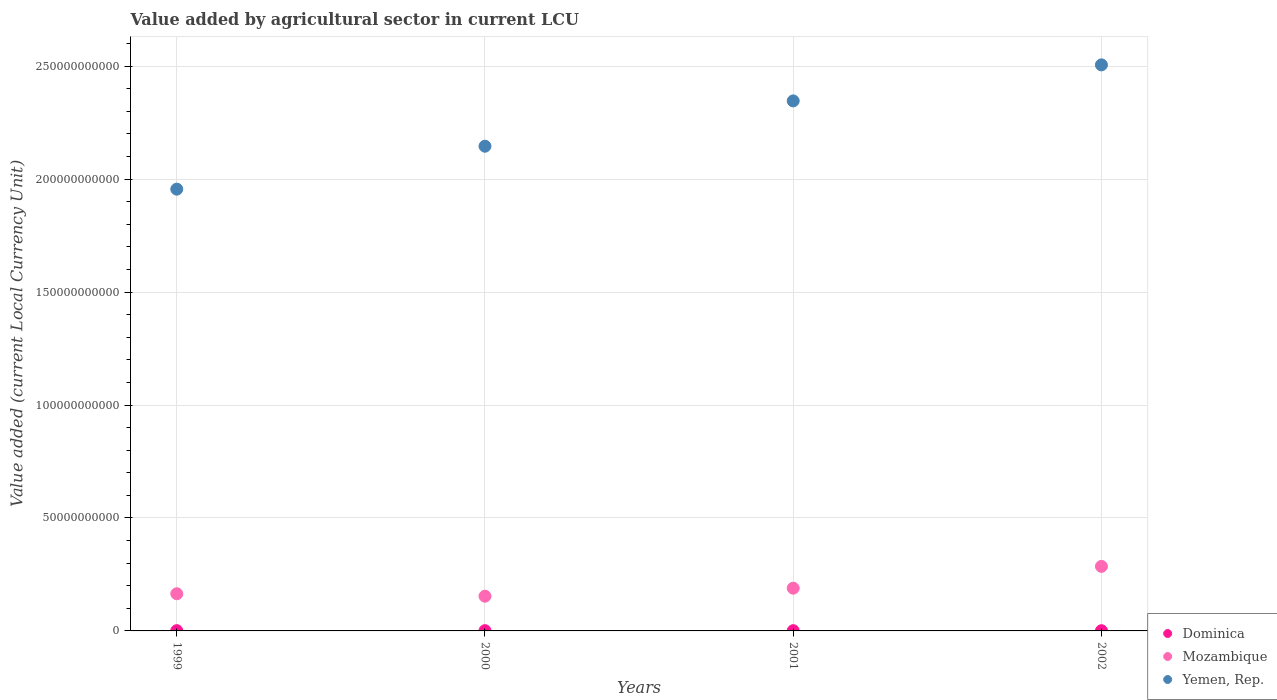Is the number of dotlines equal to the number of legend labels?
Offer a very short reply. Yes. What is the value added by agricultural sector in Yemen, Rep. in 2000?
Provide a succinct answer. 2.15e+11. Across all years, what is the maximum value added by agricultural sector in Yemen, Rep.?
Your response must be concise. 2.51e+11. Across all years, what is the minimum value added by agricultural sector in Yemen, Rep.?
Your response must be concise. 1.96e+11. In which year was the value added by agricultural sector in Yemen, Rep. maximum?
Provide a succinct answer. 2002. What is the total value added by agricultural sector in Dominica in the graph?
Your answer should be very brief. 4.23e+08. What is the difference between the value added by agricultural sector in Yemen, Rep. in 2000 and that in 2001?
Provide a short and direct response. -2.01e+1. What is the difference between the value added by agricultural sector in Dominica in 2002 and the value added by agricultural sector in Mozambique in 1999?
Your answer should be compact. -1.64e+1. What is the average value added by agricultural sector in Yemen, Rep. per year?
Your answer should be compact. 2.24e+11. In the year 1999, what is the difference between the value added by agricultural sector in Mozambique and value added by agricultural sector in Dominica?
Offer a very short reply. 1.63e+1. What is the ratio of the value added by agricultural sector in Dominica in 1999 to that in 2002?
Keep it short and to the point. 1.17. Is the difference between the value added by agricultural sector in Mozambique in 1999 and 2001 greater than the difference between the value added by agricultural sector in Dominica in 1999 and 2001?
Provide a succinct answer. No. What is the difference between the highest and the second highest value added by agricultural sector in Dominica?
Your answer should be very brief. 6.93e+06. What is the difference between the highest and the lowest value added by agricultural sector in Yemen, Rep.?
Ensure brevity in your answer.  5.50e+1. Is the sum of the value added by agricultural sector in Dominica in 1999 and 2001 greater than the maximum value added by agricultural sector in Yemen, Rep. across all years?
Your response must be concise. No. Does the value added by agricultural sector in Mozambique monotonically increase over the years?
Provide a short and direct response. No. How many dotlines are there?
Your response must be concise. 3. How many years are there in the graph?
Offer a very short reply. 4. What is the difference between two consecutive major ticks on the Y-axis?
Offer a very short reply. 5.00e+1. Are the values on the major ticks of Y-axis written in scientific E-notation?
Offer a terse response. No. Does the graph contain any zero values?
Ensure brevity in your answer.  No. What is the title of the graph?
Make the answer very short. Value added by agricultural sector in current LCU. What is the label or title of the X-axis?
Provide a succinct answer. Years. What is the label or title of the Y-axis?
Give a very brief answer. Value added (current Local Currency Unit). What is the Value added (current Local Currency Unit) of Dominica in 1999?
Ensure brevity in your answer.  1.14e+08. What is the Value added (current Local Currency Unit) of Mozambique in 1999?
Offer a very short reply. 1.65e+1. What is the Value added (current Local Currency Unit) in Yemen, Rep. in 1999?
Give a very brief answer. 1.96e+11. What is the Value added (current Local Currency Unit) in Dominica in 2000?
Your answer should be compact. 1.07e+08. What is the Value added (current Local Currency Unit) of Mozambique in 2000?
Give a very brief answer. 1.54e+1. What is the Value added (current Local Currency Unit) of Yemen, Rep. in 2000?
Make the answer very short. 2.15e+11. What is the Value added (current Local Currency Unit) of Dominica in 2001?
Give a very brief answer. 1.04e+08. What is the Value added (current Local Currency Unit) of Mozambique in 2001?
Provide a short and direct response. 1.89e+1. What is the Value added (current Local Currency Unit) in Yemen, Rep. in 2001?
Offer a terse response. 2.35e+11. What is the Value added (current Local Currency Unit) in Dominica in 2002?
Ensure brevity in your answer.  9.75e+07. What is the Value added (current Local Currency Unit) in Mozambique in 2002?
Provide a succinct answer. 2.86e+1. What is the Value added (current Local Currency Unit) in Yemen, Rep. in 2002?
Your response must be concise. 2.51e+11. Across all years, what is the maximum Value added (current Local Currency Unit) in Dominica?
Provide a succinct answer. 1.14e+08. Across all years, what is the maximum Value added (current Local Currency Unit) of Mozambique?
Keep it short and to the point. 2.86e+1. Across all years, what is the maximum Value added (current Local Currency Unit) in Yemen, Rep.?
Your answer should be very brief. 2.51e+11. Across all years, what is the minimum Value added (current Local Currency Unit) in Dominica?
Give a very brief answer. 9.75e+07. Across all years, what is the minimum Value added (current Local Currency Unit) of Mozambique?
Offer a terse response. 1.54e+1. Across all years, what is the minimum Value added (current Local Currency Unit) in Yemen, Rep.?
Offer a terse response. 1.96e+11. What is the total Value added (current Local Currency Unit) in Dominica in the graph?
Ensure brevity in your answer.  4.23e+08. What is the total Value added (current Local Currency Unit) in Mozambique in the graph?
Your response must be concise. 7.93e+1. What is the total Value added (current Local Currency Unit) of Yemen, Rep. in the graph?
Give a very brief answer. 8.95e+11. What is the difference between the Value added (current Local Currency Unit) of Dominica in 1999 and that in 2000?
Your answer should be very brief. 6.93e+06. What is the difference between the Value added (current Local Currency Unit) in Mozambique in 1999 and that in 2000?
Your response must be concise. 1.09e+09. What is the difference between the Value added (current Local Currency Unit) of Yemen, Rep. in 1999 and that in 2000?
Make the answer very short. -1.90e+1. What is the difference between the Value added (current Local Currency Unit) of Dominica in 1999 and that in 2001?
Offer a terse response. 1.04e+07. What is the difference between the Value added (current Local Currency Unit) in Mozambique in 1999 and that in 2001?
Provide a succinct answer. -2.47e+09. What is the difference between the Value added (current Local Currency Unit) of Yemen, Rep. in 1999 and that in 2001?
Offer a very short reply. -3.91e+1. What is the difference between the Value added (current Local Currency Unit) of Dominica in 1999 and that in 2002?
Make the answer very short. 1.66e+07. What is the difference between the Value added (current Local Currency Unit) in Mozambique in 1999 and that in 2002?
Your answer should be very brief. -1.21e+1. What is the difference between the Value added (current Local Currency Unit) of Yemen, Rep. in 1999 and that in 2002?
Your response must be concise. -5.50e+1. What is the difference between the Value added (current Local Currency Unit) of Dominica in 2000 and that in 2001?
Your answer should be compact. 3.43e+06. What is the difference between the Value added (current Local Currency Unit) in Mozambique in 2000 and that in 2001?
Your response must be concise. -3.56e+09. What is the difference between the Value added (current Local Currency Unit) in Yemen, Rep. in 2000 and that in 2001?
Offer a very short reply. -2.01e+1. What is the difference between the Value added (current Local Currency Unit) in Dominica in 2000 and that in 2002?
Make the answer very short. 9.66e+06. What is the difference between the Value added (current Local Currency Unit) in Mozambique in 2000 and that in 2002?
Make the answer very short. -1.32e+1. What is the difference between the Value added (current Local Currency Unit) of Yemen, Rep. in 2000 and that in 2002?
Your answer should be very brief. -3.60e+1. What is the difference between the Value added (current Local Currency Unit) of Dominica in 2001 and that in 2002?
Your answer should be very brief. 6.23e+06. What is the difference between the Value added (current Local Currency Unit) of Mozambique in 2001 and that in 2002?
Your answer should be very brief. -9.65e+09. What is the difference between the Value added (current Local Currency Unit) in Yemen, Rep. in 2001 and that in 2002?
Offer a very short reply. -1.60e+1. What is the difference between the Value added (current Local Currency Unit) of Dominica in 1999 and the Value added (current Local Currency Unit) of Mozambique in 2000?
Provide a short and direct response. -1.53e+1. What is the difference between the Value added (current Local Currency Unit) in Dominica in 1999 and the Value added (current Local Currency Unit) in Yemen, Rep. in 2000?
Make the answer very short. -2.14e+11. What is the difference between the Value added (current Local Currency Unit) in Mozambique in 1999 and the Value added (current Local Currency Unit) in Yemen, Rep. in 2000?
Your response must be concise. -1.98e+11. What is the difference between the Value added (current Local Currency Unit) of Dominica in 1999 and the Value added (current Local Currency Unit) of Mozambique in 2001?
Keep it short and to the point. -1.88e+1. What is the difference between the Value added (current Local Currency Unit) in Dominica in 1999 and the Value added (current Local Currency Unit) in Yemen, Rep. in 2001?
Offer a very short reply. -2.34e+11. What is the difference between the Value added (current Local Currency Unit) in Mozambique in 1999 and the Value added (current Local Currency Unit) in Yemen, Rep. in 2001?
Ensure brevity in your answer.  -2.18e+11. What is the difference between the Value added (current Local Currency Unit) of Dominica in 1999 and the Value added (current Local Currency Unit) of Mozambique in 2002?
Offer a very short reply. -2.85e+1. What is the difference between the Value added (current Local Currency Unit) in Dominica in 1999 and the Value added (current Local Currency Unit) in Yemen, Rep. in 2002?
Keep it short and to the point. -2.50e+11. What is the difference between the Value added (current Local Currency Unit) of Mozambique in 1999 and the Value added (current Local Currency Unit) of Yemen, Rep. in 2002?
Ensure brevity in your answer.  -2.34e+11. What is the difference between the Value added (current Local Currency Unit) in Dominica in 2000 and the Value added (current Local Currency Unit) in Mozambique in 2001?
Your response must be concise. -1.88e+1. What is the difference between the Value added (current Local Currency Unit) in Dominica in 2000 and the Value added (current Local Currency Unit) in Yemen, Rep. in 2001?
Ensure brevity in your answer.  -2.35e+11. What is the difference between the Value added (current Local Currency Unit) of Mozambique in 2000 and the Value added (current Local Currency Unit) of Yemen, Rep. in 2001?
Offer a terse response. -2.19e+11. What is the difference between the Value added (current Local Currency Unit) of Dominica in 2000 and the Value added (current Local Currency Unit) of Mozambique in 2002?
Offer a very short reply. -2.85e+1. What is the difference between the Value added (current Local Currency Unit) in Dominica in 2000 and the Value added (current Local Currency Unit) in Yemen, Rep. in 2002?
Make the answer very short. -2.50e+11. What is the difference between the Value added (current Local Currency Unit) of Mozambique in 2000 and the Value added (current Local Currency Unit) of Yemen, Rep. in 2002?
Make the answer very short. -2.35e+11. What is the difference between the Value added (current Local Currency Unit) in Dominica in 2001 and the Value added (current Local Currency Unit) in Mozambique in 2002?
Offer a very short reply. -2.85e+1. What is the difference between the Value added (current Local Currency Unit) in Dominica in 2001 and the Value added (current Local Currency Unit) in Yemen, Rep. in 2002?
Offer a terse response. -2.50e+11. What is the difference between the Value added (current Local Currency Unit) of Mozambique in 2001 and the Value added (current Local Currency Unit) of Yemen, Rep. in 2002?
Offer a terse response. -2.32e+11. What is the average Value added (current Local Currency Unit) of Dominica per year?
Keep it short and to the point. 1.06e+08. What is the average Value added (current Local Currency Unit) of Mozambique per year?
Your response must be concise. 1.98e+1. What is the average Value added (current Local Currency Unit) in Yemen, Rep. per year?
Your response must be concise. 2.24e+11. In the year 1999, what is the difference between the Value added (current Local Currency Unit) in Dominica and Value added (current Local Currency Unit) in Mozambique?
Offer a terse response. -1.63e+1. In the year 1999, what is the difference between the Value added (current Local Currency Unit) of Dominica and Value added (current Local Currency Unit) of Yemen, Rep.?
Your response must be concise. -1.95e+11. In the year 1999, what is the difference between the Value added (current Local Currency Unit) in Mozambique and Value added (current Local Currency Unit) in Yemen, Rep.?
Provide a succinct answer. -1.79e+11. In the year 2000, what is the difference between the Value added (current Local Currency Unit) of Dominica and Value added (current Local Currency Unit) of Mozambique?
Your response must be concise. -1.53e+1. In the year 2000, what is the difference between the Value added (current Local Currency Unit) of Dominica and Value added (current Local Currency Unit) of Yemen, Rep.?
Make the answer very short. -2.14e+11. In the year 2000, what is the difference between the Value added (current Local Currency Unit) in Mozambique and Value added (current Local Currency Unit) in Yemen, Rep.?
Provide a succinct answer. -1.99e+11. In the year 2001, what is the difference between the Value added (current Local Currency Unit) of Dominica and Value added (current Local Currency Unit) of Mozambique?
Offer a terse response. -1.88e+1. In the year 2001, what is the difference between the Value added (current Local Currency Unit) of Dominica and Value added (current Local Currency Unit) of Yemen, Rep.?
Provide a short and direct response. -2.35e+11. In the year 2001, what is the difference between the Value added (current Local Currency Unit) in Mozambique and Value added (current Local Currency Unit) in Yemen, Rep.?
Provide a short and direct response. -2.16e+11. In the year 2002, what is the difference between the Value added (current Local Currency Unit) in Dominica and Value added (current Local Currency Unit) in Mozambique?
Offer a very short reply. -2.85e+1. In the year 2002, what is the difference between the Value added (current Local Currency Unit) of Dominica and Value added (current Local Currency Unit) of Yemen, Rep.?
Offer a very short reply. -2.50e+11. In the year 2002, what is the difference between the Value added (current Local Currency Unit) of Mozambique and Value added (current Local Currency Unit) of Yemen, Rep.?
Ensure brevity in your answer.  -2.22e+11. What is the ratio of the Value added (current Local Currency Unit) of Dominica in 1999 to that in 2000?
Make the answer very short. 1.06. What is the ratio of the Value added (current Local Currency Unit) of Mozambique in 1999 to that in 2000?
Offer a terse response. 1.07. What is the ratio of the Value added (current Local Currency Unit) in Yemen, Rep. in 1999 to that in 2000?
Provide a succinct answer. 0.91. What is the ratio of the Value added (current Local Currency Unit) in Dominica in 1999 to that in 2001?
Give a very brief answer. 1.1. What is the ratio of the Value added (current Local Currency Unit) of Mozambique in 1999 to that in 2001?
Provide a succinct answer. 0.87. What is the ratio of the Value added (current Local Currency Unit) of Yemen, Rep. in 1999 to that in 2001?
Offer a very short reply. 0.83. What is the ratio of the Value added (current Local Currency Unit) of Dominica in 1999 to that in 2002?
Make the answer very short. 1.17. What is the ratio of the Value added (current Local Currency Unit) in Mozambique in 1999 to that in 2002?
Offer a very short reply. 0.58. What is the ratio of the Value added (current Local Currency Unit) in Yemen, Rep. in 1999 to that in 2002?
Provide a short and direct response. 0.78. What is the ratio of the Value added (current Local Currency Unit) of Dominica in 2000 to that in 2001?
Provide a short and direct response. 1.03. What is the ratio of the Value added (current Local Currency Unit) in Mozambique in 2000 to that in 2001?
Your answer should be very brief. 0.81. What is the ratio of the Value added (current Local Currency Unit) in Yemen, Rep. in 2000 to that in 2001?
Provide a succinct answer. 0.91. What is the ratio of the Value added (current Local Currency Unit) of Dominica in 2000 to that in 2002?
Offer a very short reply. 1.1. What is the ratio of the Value added (current Local Currency Unit) of Mozambique in 2000 to that in 2002?
Ensure brevity in your answer.  0.54. What is the ratio of the Value added (current Local Currency Unit) of Yemen, Rep. in 2000 to that in 2002?
Give a very brief answer. 0.86. What is the ratio of the Value added (current Local Currency Unit) of Dominica in 2001 to that in 2002?
Keep it short and to the point. 1.06. What is the ratio of the Value added (current Local Currency Unit) in Mozambique in 2001 to that in 2002?
Provide a succinct answer. 0.66. What is the ratio of the Value added (current Local Currency Unit) of Yemen, Rep. in 2001 to that in 2002?
Provide a short and direct response. 0.94. What is the difference between the highest and the second highest Value added (current Local Currency Unit) of Dominica?
Ensure brevity in your answer.  6.93e+06. What is the difference between the highest and the second highest Value added (current Local Currency Unit) in Mozambique?
Give a very brief answer. 9.65e+09. What is the difference between the highest and the second highest Value added (current Local Currency Unit) in Yemen, Rep.?
Provide a short and direct response. 1.60e+1. What is the difference between the highest and the lowest Value added (current Local Currency Unit) of Dominica?
Make the answer very short. 1.66e+07. What is the difference between the highest and the lowest Value added (current Local Currency Unit) of Mozambique?
Provide a succinct answer. 1.32e+1. What is the difference between the highest and the lowest Value added (current Local Currency Unit) of Yemen, Rep.?
Your answer should be compact. 5.50e+1. 